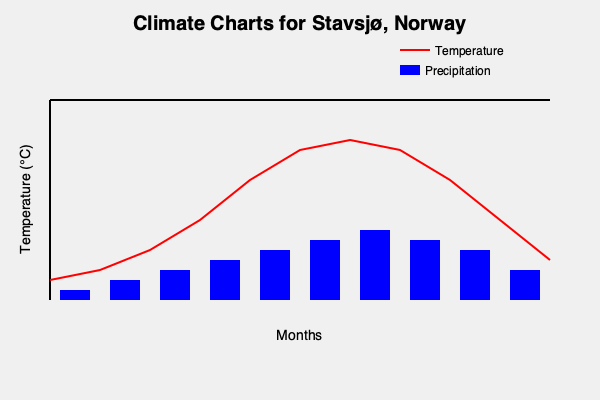Based on the climate charts for Stavsjø, Norway, which month is likely to have the highest precipitation, and how does this correlate with the temperature pattern? To answer this question, we need to analyze both the temperature and precipitation patterns shown in the climate charts:

1. Temperature pattern:
   - The red line represents temperature throughout the year.
   - It shows a typical Northern Hemisphere pattern with cooler temperatures in winter and warmer in summer.
   - The lowest point is around January-February, and the highest is around July-August.

2. Precipitation pattern:
   - The blue bars represent precipitation levels for each month.
   - We can see that the precipitation levels vary throughout the year.
   - The tallest blue bar, indicating the highest precipitation, appears to be in July or August.

3. Correlation between temperature and precipitation:
   - The highest precipitation coincides with the warmest temperatures.
   - This suggests a summer maximum in both temperature and precipitation.

4. Interpreting the pattern:
   - In Norway, summer months often bring more rainfall due to increased convection and moisture in the warmer air.
   - The warmest month (likely July or August) also appears to be the wettest.

5. Conclusion:
   - Based on the chart, August seems to have the highest precipitation.
   - This correlates positively with the temperature pattern, as August is also one of the warmest months.

This pattern is typical for many parts of Norway, where summer brings both warmer temperatures and increased rainfall.
Answer: August; positive correlation with temperature 